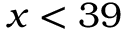Convert formula to latex. <formula><loc_0><loc_0><loc_500><loc_500>x < 3 9</formula> 